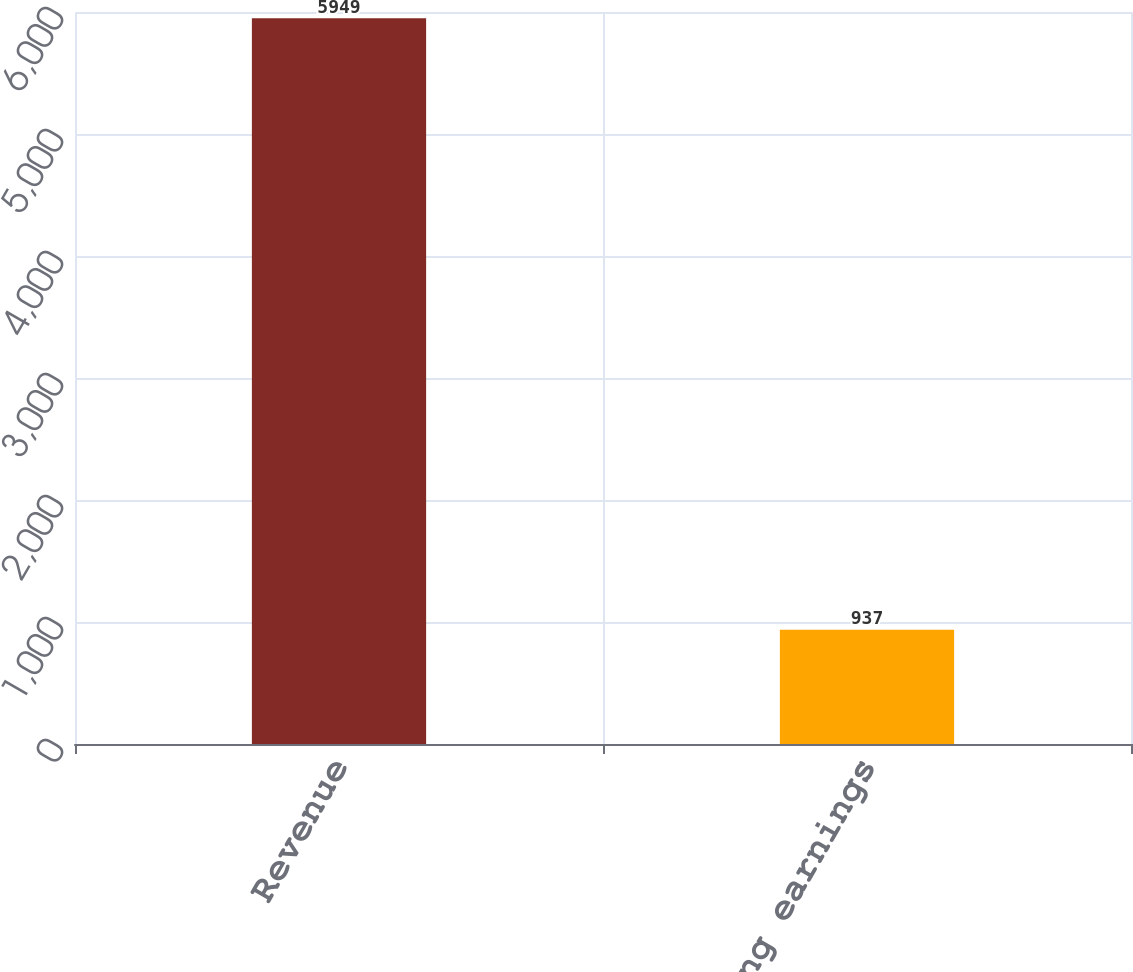Convert chart. <chart><loc_0><loc_0><loc_500><loc_500><bar_chart><fcel>Revenue<fcel>Operating earnings<nl><fcel>5949<fcel>937<nl></chart> 